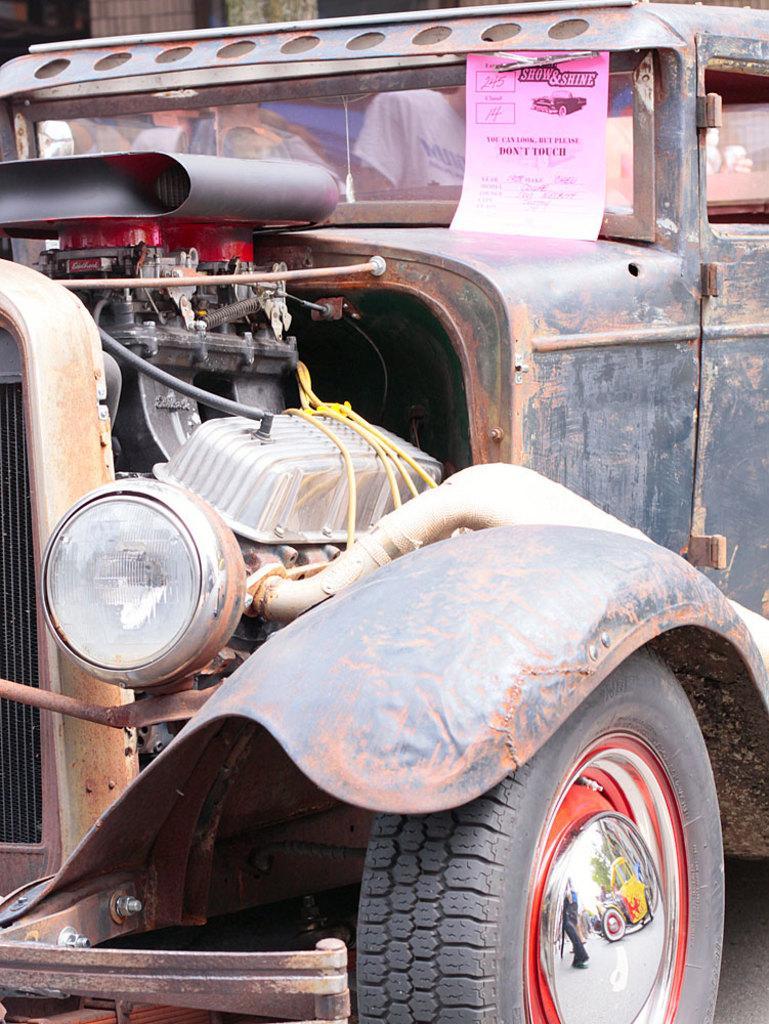Describe this image in one or two sentences. In this image there is vehicle. We can see headlamp and tyre. There are people sitting. 